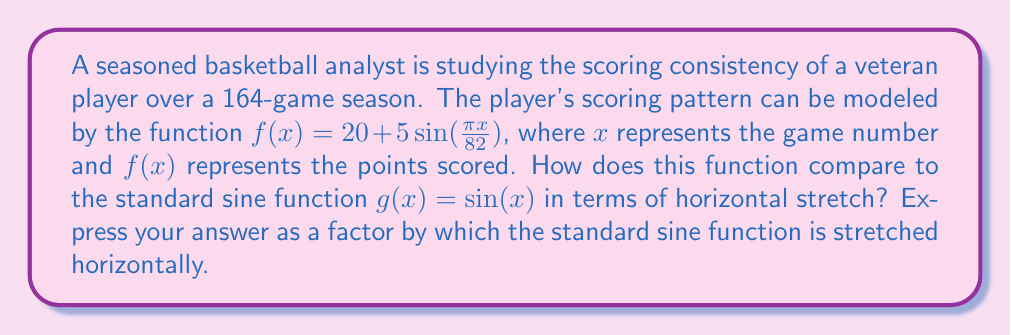Give your solution to this math problem. To determine the horizontal stretch, we need to compare the given function to the standard sine function:

1) The given function: $f(x) = 20 + 5\sin(\frac{\pi x}{82})$
2) Standard sine function: $g(x) = \sin(x)$

3) In the general form of a sine function, $a\sin(b(x-c))+d$, the parameter $b$ determines the horizontal stretch. A smaller $b$ results in a larger stretch.

4) In our function $f(x)$, $b = \frac{\pi}{82}$

5) The horizontal stretch factor is the reciprocal of $b$:

   Stretch factor = $\frac{1}{b} = \frac{1}{\frac{\pi}{82}} = \frac{82}{\pi}$

6) This means that the standard sine function is stretched horizontally by a factor of $\frac{82}{\pi}$ to obtain the given function (ignoring vertical stretch and vertical shift).
Answer: $\frac{82}{\pi}$ 